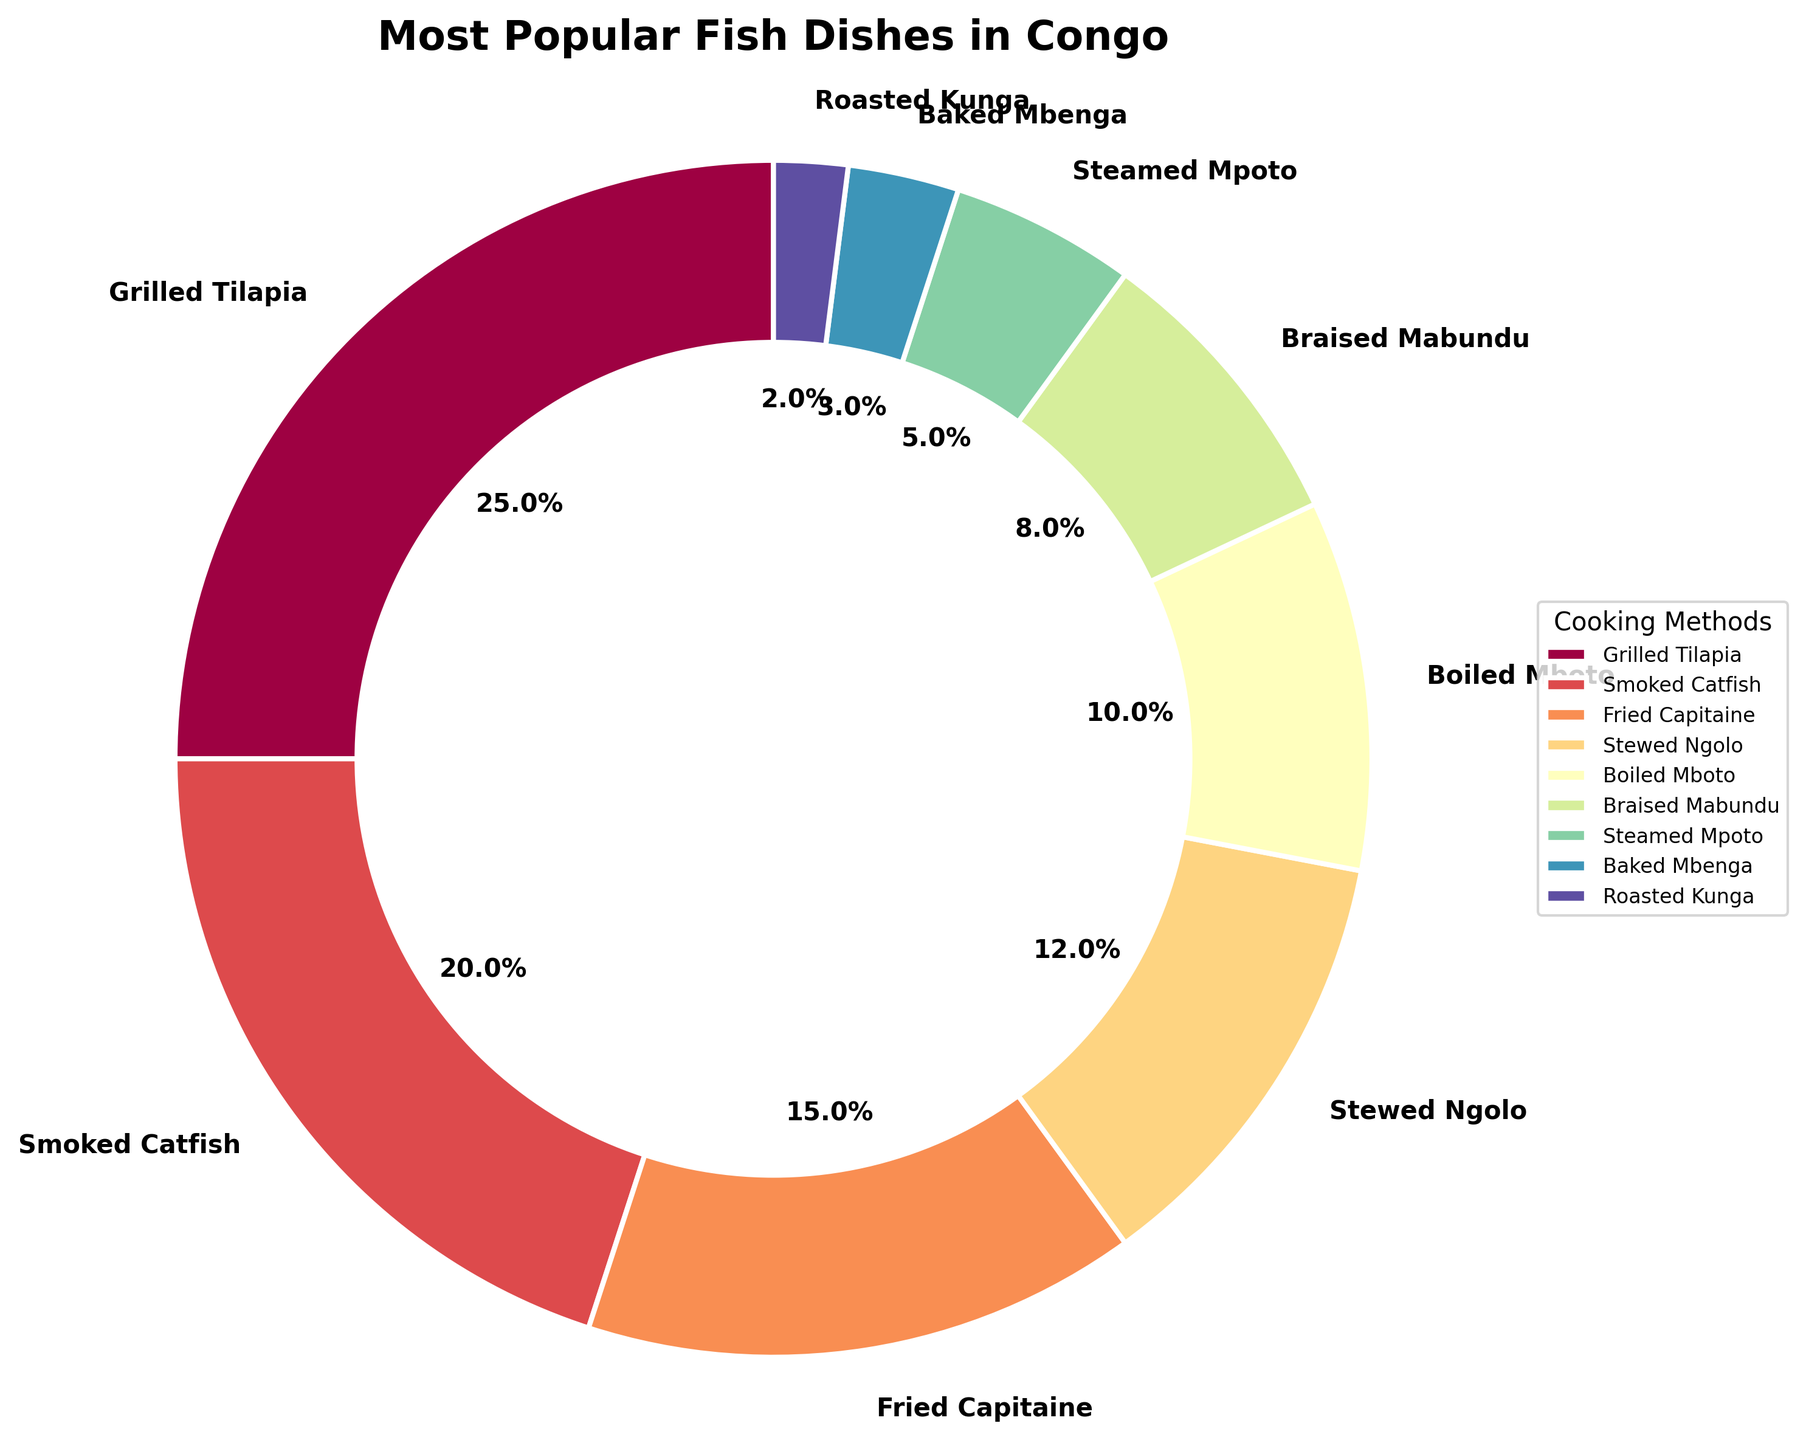What cooking method has the highest percentage of popularity? The pie chart section for Grilled Tilapia is the largest, taking up 25%.
Answer: Grilled Tilapia Which cooking method is more popular, Smoked Catfish or Fried Capitaine? Smoked Catfish has a larger section in the pie chart, accounting for 20%, while Fried Capitaine is 15%.
Answer: Smoked Catfish What is the total percentage of the three least popular cooking methods? The percentage for the three least popular methods (Roasted Kunga, Baked Mbenga, and Steamed Mpoto) are 2%, 3%, and 5% respectively. Summing them up, 2 + 3 + 5 = 10%.
Answer: 10% Is the percentage of Stewed Ngolo more than the combined percentage of Boiled Mboto and Braised Mabundu? The percentage for Stewed Ngolo is 12%. The combined percentage for Boiled Mboto (10%) and Braised Mabundu (8%) is 10 + 8 = 18%. Since 12% is less than 18%, Stewed Ngolo's percentage is not higher.
Answer: No Which cooking method occupies the smallest section of the pie chart? The smallest section in the pie chart corresponds to Roasted Kunga, which has a percentage of 2%.
Answer: Roasted Kunga What's the difference in percentage between Grilled Tilapia and Stewed Ngolo? Grilled Tilapia has 25%, and Stewed Ngolo has 12%. The difference is 25 - 12 = 13%.
Answer: 13% Between which two consecutive cooking methods in the chart is there the largest difference in percentage? The two consecutive methods with the largest difference are Grilled Tilapia (25%) and Smoked Catfish (20%), with a difference of 25 - 20 = 5%.
Answer: Grilled Tilapia and Smoked Catfish What is the percentage representation of cooking methods that involve some form of smoking or grilling (Grilled Tilapia and Smoked Catfish)? Grilled Tilapia is 25% and Smoked Catfish is 20%. Their combined percentage is 25 + 20 = 45%.
Answer: 45% Which two cooking methods combined make up 30% of the chart? Both Fried Capitaine (15%) and Stewed Ngolo (12%) add up to 15 + 12 = 27%, which is the closest to 30%. Adjusting for the exact value we consider Fried Capitaine (15%) and Boiled Mboto (10%) adding 15 + 10 = 25% or wider brackets Fried Capitaine (15%) and Braised Mabundu (8%) giving 15 + 8 = 23%. For more closest exact value consideration for larger values you would combine Smoked Catfish (20%) and Stewed Ngolo (12%) giving 20 + 12 = 32% close to adding Fried Capitaine (15%) and Boiled Mboto (10%) and including Steamed Mpoto (5%) giving 30%.
Answer: Smoked Catfish and Stewed Ngolo 